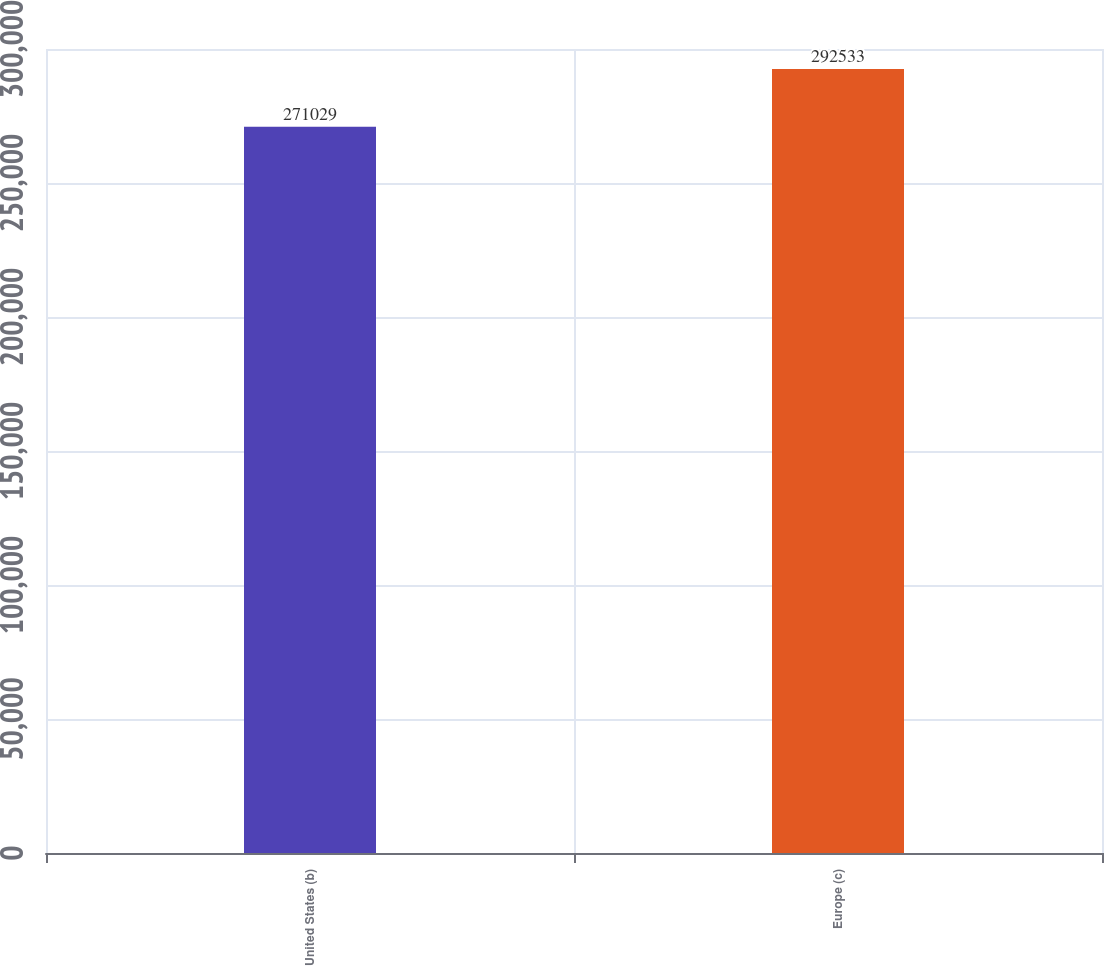<chart> <loc_0><loc_0><loc_500><loc_500><bar_chart><fcel>United States (b)<fcel>Europe (c)<nl><fcel>271029<fcel>292533<nl></chart> 